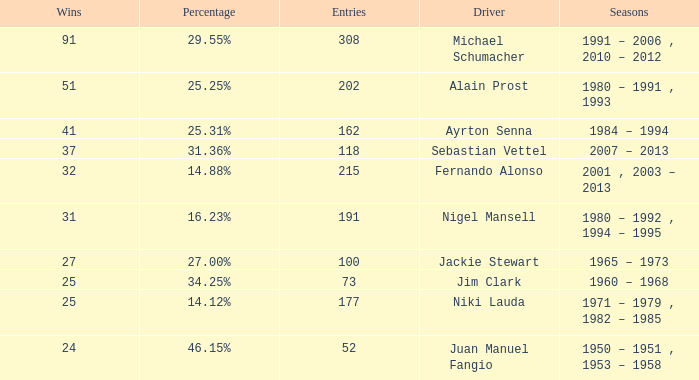Which driver has less than 37 wins and at 14.12%? 177.0. Can you parse all the data within this table? {'header': ['Wins', 'Percentage', 'Entries', 'Driver', 'Seasons'], 'rows': [['91', '29.55%', '308', 'Michael Schumacher', '1991 – 2006 , 2010 – 2012'], ['51', '25.25%', '202', 'Alain Prost', '1980 – 1991 , 1993'], ['41', '25.31%', '162', 'Ayrton Senna', '1984 – 1994'], ['37', '31.36%', '118', 'Sebastian Vettel', '2007 – 2013'], ['32', '14.88%', '215', 'Fernando Alonso', '2001 , 2003 – 2013'], ['31', '16.23%', '191', 'Nigel Mansell', '1980 – 1992 , 1994 – 1995'], ['27', '27.00%', '100', 'Jackie Stewart', '1965 – 1973'], ['25', '34.25%', '73', 'Jim Clark', '1960 – 1968'], ['25', '14.12%', '177', 'Niki Lauda', '1971 – 1979 , 1982 – 1985'], ['24', '46.15%', '52', 'Juan Manuel Fangio', '1950 – 1951 , 1953 – 1958']]} 